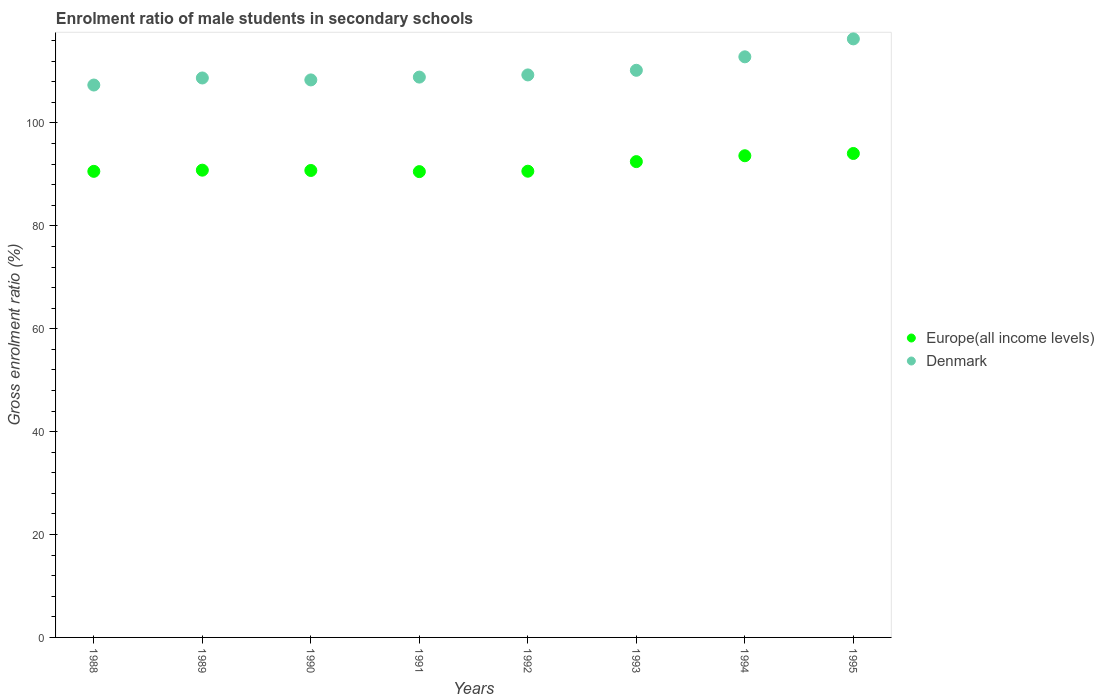How many different coloured dotlines are there?
Your response must be concise. 2. What is the enrolment ratio of male students in secondary schools in Denmark in 1990?
Your answer should be very brief. 108.37. Across all years, what is the maximum enrolment ratio of male students in secondary schools in Denmark?
Provide a succinct answer. 116.35. Across all years, what is the minimum enrolment ratio of male students in secondary schools in Europe(all income levels)?
Your answer should be very brief. 90.55. What is the total enrolment ratio of male students in secondary schools in Denmark in the graph?
Make the answer very short. 882.23. What is the difference between the enrolment ratio of male students in secondary schools in Europe(all income levels) in 1988 and that in 1991?
Keep it short and to the point. 0.05. What is the difference between the enrolment ratio of male students in secondary schools in Europe(all income levels) in 1989 and the enrolment ratio of male students in secondary schools in Denmark in 1990?
Provide a short and direct response. -17.54. What is the average enrolment ratio of male students in secondary schools in Denmark per year?
Your response must be concise. 110.28. In the year 1991, what is the difference between the enrolment ratio of male students in secondary schools in Europe(all income levels) and enrolment ratio of male students in secondary schools in Denmark?
Your answer should be very brief. -18.37. What is the ratio of the enrolment ratio of male students in secondary schools in Europe(all income levels) in 1993 to that in 1994?
Keep it short and to the point. 0.99. What is the difference between the highest and the second highest enrolment ratio of male students in secondary schools in Denmark?
Ensure brevity in your answer.  3.49. What is the difference between the highest and the lowest enrolment ratio of male students in secondary schools in Europe(all income levels)?
Provide a succinct answer. 3.52. Is the sum of the enrolment ratio of male students in secondary schools in Denmark in 1989 and 1993 greater than the maximum enrolment ratio of male students in secondary schools in Europe(all income levels) across all years?
Make the answer very short. Yes. Does the enrolment ratio of male students in secondary schools in Denmark monotonically increase over the years?
Your answer should be compact. No. Is the enrolment ratio of male students in secondary schools in Denmark strictly greater than the enrolment ratio of male students in secondary schools in Europe(all income levels) over the years?
Your response must be concise. Yes. How many dotlines are there?
Offer a very short reply. 2. What is the difference between two consecutive major ticks on the Y-axis?
Your answer should be compact. 20. Does the graph contain grids?
Your answer should be compact. No. How many legend labels are there?
Your response must be concise. 2. How are the legend labels stacked?
Make the answer very short. Vertical. What is the title of the graph?
Your answer should be very brief. Enrolment ratio of male students in secondary schools. What is the Gross enrolment ratio (%) of Europe(all income levels) in 1988?
Give a very brief answer. 90.6. What is the Gross enrolment ratio (%) of Denmark in 1988?
Offer a terse response. 107.38. What is the Gross enrolment ratio (%) of Europe(all income levels) in 1989?
Ensure brevity in your answer.  90.83. What is the Gross enrolment ratio (%) of Denmark in 1989?
Give a very brief answer. 108.75. What is the Gross enrolment ratio (%) in Europe(all income levels) in 1990?
Provide a succinct answer. 90.77. What is the Gross enrolment ratio (%) in Denmark in 1990?
Offer a terse response. 108.37. What is the Gross enrolment ratio (%) of Europe(all income levels) in 1991?
Give a very brief answer. 90.55. What is the Gross enrolment ratio (%) in Denmark in 1991?
Offer a very short reply. 108.92. What is the Gross enrolment ratio (%) of Europe(all income levels) in 1992?
Make the answer very short. 90.63. What is the Gross enrolment ratio (%) in Denmark in 1992?
Provide a succinct answer. 109.35. What is the Gross enrolment ratio (%) in Europe(all income levels) in 1993?
Your answer should be compact. 92.49. What is the Gross enrolment ratio (%) of Denmark in 1993?
Offer a terse response. 110.25. What is the Gross enrolment ratio (%) in Europe(all income levels) in 1994?
Offer a terse response. 93.63. What is the Gross enrolment ratio (%) in Denmark in 1994?
Ensure brevity in your answer.  112.86. What is the Gross enrolment ratio (%) in Europe(all income levels) in 1995?
Your answer should be very brief. 94.07. What is the Gross enrolment ratio (%) in Denmark in 1995?
Your answer should be compact. 116.35. Across all years, what is the maximum Gross enrolment ratio (%) in Europe(all income levels)?
Provide a succinct answer. 94.07. Across all years, what is the maximum Gross enrolment ratio (%) of Denmark?
Give a very brief answer. 116.35. Across all years, what is the minimum Gross enrolment ratio (%) of Europe(all income levels)?
Provide a succinct answer. 90.55. Across all years, what is the minimum Gross enrolment ratio (%) of Denmark?
Your response must be concise. 107.38. What is the total Gross enrolment ratio (%) in Europe(all income levels) in the graph?
Your answer should be compact. 733.58. What is the total Gross enrolment ratio (%) of Denmark in the graph?
Your answer should be compact. 882.23. What is the difference between the Gross enrolment ratio (%) in Europe(all income levels) in 1988 and that in 1989?
Give a very brief answer. -0.23. What is the difference between the Gross enrolment ratio (%) in Denmark in 1988 and that in 1989?
Your response must be concise. -1.37. What is the difference between the Gross enrolment ratio (%) in Europe(all income levels) in 1988 and that in 1990?
Your answer should be very brief. -0.17. What is the difference between the Gross enrolment ratio (%) of Denmark in 1988 and that in 1990?
Make the answer very short. -0.99. What is the difference between the Gross enrolment ratio (%) in Europe(all income levels) in 1988 and that in 1991?
Provide a short and direct response. 0.05. What is the difference between the Gross enrolment ratio (%) of Denmark in 1988 and that in 1991?
Your answer should be compact. -1.54. What is the difference between the Gross enrolment ratio (%) in Europe(all income levels) in 1988 and that in 1992?
Ensure brevity in your answer.  -0.03. What is the difference between the Gross enrolment ratio (%) in Denmark in 1988 and that in 1992?
Keep it short and to the point. -1.97. What is the difference between the Gross enrolment ratio (%) of Europe(all income levels) in 1988 and that in 1993?
Ensure brevity in your answer.  -1.89. What is the difference between the Gross enrolment ratio (%) in Denmark in 1988 and that in 1993?
Your answer should be very brief. -2.87. What is the difference between the Gross enrolment ratio (%) of Europe(all income levels) in 1988 and that in 1994?
Your answer should be compact. -3.03. What is the difference between the Gross enrolment ratio (%) in Denmark in 1988 and that in 1994?
Offer a very short reply. -5.48. What is the difference between the Gross enrolment ratio (%) of Europe(all income levels) in 1988 and that in 1995?
Give a very brief answer. -3.47. What is the difference between the Gross enrolment ratio (%) in Denmark in 1988 and that in 1995?
Give a very brief answer. -8.97. What is the difference between the Gross enrolment ratio (%) of Europe(all income levels) in 1989 and that in 1990?
Give a very brief answer. 0.06. What is the difference between the Gross enrolment ratio (%) of Denmark in 1989 and that in 1990?
Your response must be concise. 0.38. What is the difference between the Gross enrolment ratio (%) in Europe(all income levels) in 1989 and that in 1991?
Ensure brevity in your answer.  0.28. What is the difference between the Gross enrolment ratio (%) of Denmark in 1989 and that in 1991?
Ensure brevity in your answer.  -0.17. What is the difference between the Gross enrolment ratio (%) of Europe(all income levels) in 1989 and that in 1992?
Your response must be concise. 0.2. What is the difference between the Gross enrolment ratio (%) of Denmark in 1989 and that in 1992?
Provide a short and direct response. -0.59. What is the difference between the Gross enrolment ratio (%) in Europe(all income levels) in 1989 and that in 1993?
Your answer should be very brief. -1.66. What is the difference between the Gross enrolment ratio (%) of Denmark in 1989 and that in 1993?
Make the answer very short. -1.49. What is the difference between the Gross enrolment ratio (%) in Europe(all income levels) in 1989 and that in 1994?
Ensure brevity in your answer.  -2.8. What is the difference between the Gross enrolment ratio (%) of Denmark in 1989 and that in 1994?
Make the answer very short. -4.11. What is the difference between the Gross enrolment ratio (%) in Europe(all income levels) in 1989 and that in 1995?
Offer a very short reply. -3.24. What is the difference between the Gross enrolment ratio (%) in Denmark in 1989 and that in 1995?
Ensure brevity in your answer.  -7.6. What is the difference between the Gross enrolment ratio (%) of Europe(all income levels) in 1990 and that in 1991?
Your answer should be very brief. 0.22. What is the difference between the Gross enrolment ratio (%) of Denmark in 1990 and that in 1991?
Keep it short and to the point. -0.55. What is the difference between the Gross enrolment ratio (%) in Europe(all income levels) in 1990 and that in 1992?
Make the answer very short. 0.14. What is the difference between the Gross enrolment ratio (%) in Denmark in 1990 and that in 1992?
Provide a succinct answer. -0.97. What is the difference between the Gross enrolment ratio (%) in Europe(all income levels) in 1990 and that in 1993?
Your response must be concise. -1.72. What is the difference between the Gross enrolment ratio (%) in Denmark in 1990 and that in 1993?
Provide a short and direct response. -1.87. What is the difference between the Gross enrolment ratio (%) of Europe(all income levels) in 1990 and that in 1994?
Provide a succinct answer. -2.86. What is the difference between the Gross enrolment ratio (%) of Denmark in 1990 and that in 1994?
Keep it short and to the point. -4.49. What is the difference between the Gross enrolment ratio (%) in Europe(all income levels) in 1990 and that in 1995?
Give a very brief answer. -3.3. What is the difference between the Gross enrolment ratio (%) of Denmark in 1990 and that in 1995?
Ensure brevity in your answer.  -7.98. What is the difference between the Gross enrolment ratio (%) in Europe(all income levels) in 1991 and that in 1992?
Give a very brief answer. -0.08. What is the difference between the Gross enrolment ratio (%) in Denmark in 1991 and that in 1992?
Your response must be concise. -0.42. What is the difference between the Gross enrolment ratio (%) in Europe(all income levels) in 1991 and that in 1993?
Offer a terse response. -1.94. What is the difference between the Gross enrolment ratio (%) of Denmark in 1991 and that in 1993?
Offer a terse response. -1.33. What is the difference between the Gross enrolment ratio (%) in Europe(all income levels) in 1991 and that in 1994?
Provide a short and direct response. -3.09. What is the difference between the Gross enrolment ratio (%) in Denmark in 1991 and that in 1994?
Provide a succinct answer. -3.94. What is the difference between the Gross enrolment ratio (%) of Europe(all income levels) in 1991 and that in 1995?
Offer a terse response. -3.52. What is the difference between the Gross enrolment ratio (%) in Denmark in 1991 and that in 1995?
Make the answer very short. -7.43. What is the difference between the Gross enrolment ratio (%) in Europe(all income levels) in 1992 and that in 1993?
Your answer should be compact. -1.87. What is the difference between the Gross enrolment ratio (%) of Denmark in 1992 and that in 1993?
Offer a very short reply. -0.9. What is the difference between the Gross enrolment ratio (%) of Europe(all income levels) in 1992 and that in 1994?
Your answer should be very brief. -3.01. What is the difference between the Gross enrolment ratio (%) in Denmark in 1992 and that in 1994?
Keep it short and to the point. -3.52. What is the difference between the Gross enrolment ratio (%) in Europe(all income levels) in 1992 and that in 1995?
Your answer should be compact. -3.45. What is the difference between the Gross enrolment ratio (%) in Denmark in 1992 and that in 1995?
Provide a short and direct response. -7. What is the difference between the Gross enrolment ratio (%) in Europe(all income levels) in 1993 and that in 1994?
Ensure brevity in your answer.  -1.14. What is the difference between the Gross enrolment ratio (%) in Denmark in 1993 and that in 1994?
Your answer should be compact. -2.62. What is the difference between the Gross enrolment ratio (%) of Europe(all income levels) in 1993 and that in 1995?
Offer a very short reply. -1.58. What is the difference between the Gross enrolment ratio (%) in Denmark in 1993 and that in 1995?
Keep it short and to the point. -6.1. What is the difference between the Gross enrolment ratio (%) in Europe(all income levels) in 1994 and that in 1995?
Provide a succinct answer. -0.44. What is the difference between the Gross enrolment ratio (%) of Denmark in 1994 and that in 1995?
Make the answer very short. -3.49. What is the difference between the Gross enrolment ratio (%) in Europe(all income levels) in 1988 and the Gross enrolment ratio (%) in Denmark in 1989?
Provide a succinct answer. -18.15. What is the difference between the Gross enrolment ratio (%) of Europe(all income levels) in 1988 and the Gross enrolment ratio (%) of Denmark in 1990?
Provide a succinct answer. -17.77. What is the difference between the Gross enrolment ratio (%) in Europe(all income levels) in 1988 and the Gross enrolment ratio (%) in Denmark in 1991?
Give a very brief answer. -18.32. What is the difference between the Gross enrolment ratio (%) of Europe(all income levels) in 1988 and the Gross enrolment ratio (%) of Denmark in 1992?
Your response must be concise. -18.74. What is the difference between the Gross enrolment ratio (%) in Europe(all income levels) in 1988 and the Gross enrolment ratio (%) in Denmark in 1993?
Give a very brief answer. -19.64. What is the difference between the Gross enrolment ratio (%) of Europe(all income levels) in 1988 and the Gross enrolment ratio (%) of Denmark in 1994?
Your answer should be compact. -22.26. What is the difference between the Gross enrolment ratio (%) of Europe(all income levels) in 1988 and the Gross enrolment ratio (%) of Denmark in 1995?
Provide a succinct answer. -25.75. What is the difference between the Gross enrolment ratio (%) of Europe(all income levels) in 1989 and the Gross enrolment ratio (%) of Denmark in 1990?
Your answer should be very brief. -17.54. What is the difference between the Gross enrolment ratio (%) in Europe(all income levels) in 1989 and the Gross enrolment ratio (%) in Denmark in 1991?
Make the answer very short. -18.09. What is the difference between the Gross enrolment ratio (%) of Europe(all income levels) in 1989 and the Gross enrolment ratio (%) of Denmark in 1992?
Your response must be concise. -18.51. What is the difference between the Gross enrolment ratio (%) of Europe(all income levels) in 1989 and the Gross enrolment ratio (%) of Denmark in 1993?
Make the answer very short. -19.42. What is the difference between the Gross enrolment ratio (%) of Europe(all income levels) in 1989 and the Gross enrolment ratio (%) of Denmark in 1994?
Offer a terse response. -22.03. What is the difference between the Gross enrolment ratio (%) of Europe(all income levels) in 1989 and the Gross enrolment ratio (%) of Denmark in 1995?
Offer a very short reply. -25.52. What is the difference between the Gross enrolment ratio (%) in Europe(all income levels) in 1990 and the Gross enrolment ratio (%) in Denmark in 1991?
Your answer should be compact. -18.15. What is the difference between the Gross enrolment ratio (%) in Europe(all income levels) in 1990 and the Gross enrolment ratio (%) in Denmark in 1992?
Your response must be concise. -18.57. What is the difference between the Gross enrolment ratio (%) in Europe(all income levels) in 1990 and the Gross enrolment ratio (%) in Denmark in 1993?
Offer a very short reply. -19.48. What is the difference between the Gross enrolment ratio (%) in Europe(all income levels) in 1990 and the Gross enrolment ratio (%) in Denmark in 1994?
Give a very brief answer. -22.09. What is the difference between the Gross enrolment ratio (%) in Europe(all income levels) in 1990 and the Gross enrolment ratio (%) in Denmark in 1995?
Keep it short and to the point. -25.58. What is the difference between the Gross enrolment ratio (%) in Europe(all income levels) in 1991 and the Gross enrolment ratio (%) in Denmark in 1992?
Keep it short and to the point. -18.8. What is the difference between the Gross enrolment ratio (%) in Europe(all income levels) in 1991 and the Gross enrolment ratio (%) in Denmark in 1993?
Your response must be concise. -19.7. What is the difference between the Gross enrolment ratio (%) of Europe(all income levels) in 1991 and the Gross enrolment ratio (%) of Denmark in 1994?
Make the answer very short. -22.31. What is the difference between the Gross enrolment ratio (%) of Europe(all income levels) in 1991 and the Gross enrolment ratio (%) of Denmark in 1995?
Give a very brief answer. -25.8. What is the difference between the Gross enrolment ratio (%) in Europe(all income levels) in 1992 and the Gross enrolment ratio (%) in Denmark in 1993?
Offer a terse response. -19.62. What is the difference between the Gross enrolment ratio (%) of Europe(all income levels) in 1992 and the Gross enrolment ratio (%) of Denmark in 1994?
Offer a terse response. -22.24. What is the difference between the Gross enrolment ratio (%) of Europe(all income levels) in 1992 and the Gross enrolment ratio (%) of Denmark in 1995?
Your answer should be compact. -25.72. What is the difference between the Gross enrolment ratio (%) of Europe(all income levels) in 1993 and the Gross enrolment ratio (%) of Denmark in 1994?
Provide a succinct answer. -20.37. What is the difference between the Gross enrolment ratio (%) in Europe(all income levels) in 1993 and the Gross enrolment ratio (%) in Denmark in 1995?
Your answer should be compact. -23.86. What is the difference between the Gross enrolment ratio (%) of Europe(all income levels) in 1994 and the Gross enrolment ratio (%) of Denmark in 1995?
Ensure brevity in your answer.  -22.72. What is the average Gross enrolment ratio (%) of Europe(all income levels) per year?
Keep it short and to the point. 91.7. What is the average Gross enrolment ratio (%) in Denmark per year?
Provide a short and direct response. 110.28. In the year 1988, what is the difference between the Gross enrolment ratio (%) of Europe(all income levels) and Gross enrolment ratio (%) of Denmark?
Provide a short and direct response. -16.78. In the year 1989, what is the difference between the Gross enrolment ratio (%) in Europe(all income levels) and Gross enrolment ratio (%) in Denmark?
Give a very brief answer. -17.92. In the year 1990, what is the difference between the Gross enrolment ratio (%) in Europe(all income levels) and Gross enrolment ratio (%) in Denmark?
Your answer should be very brief. -17.6. In the year 1991, what is the difference between the Gross enrolment ratio (%) in Europe(all income levels) and Gross enrolment ratio (%) in Denmark?
Keep it short and to the point. -18.37. In the year 1992, what is the difference between the Gross enrolment ratio (%) of Europe(all income levels) and Gross enrolment ratio (%) of Denmark?
Provide a short and direct response. -18.72. In the year 1993, what is the difference between the Gross enrolment ratio (%) of Europe(all income levels) and Gross enrolment ratio (%) of Denmark?
Give a very brief answer. -17.75. In the year 1994, what is the difference between the Gross enrolment ratio (%) in Europe(all income levels) and Gross enrolment ratio (%) in Denmark?
Offer a very short reply. -19.23. In the year 1995, what is the difference between the Gross enrolment ratio (%) in Europe(all income levels) and Gross enrolment ratio (%) in Denmark?
Offer a very short reply. -22.28. What is the ratio of the Gross enrolment ratio (%) in Denmark in 1988 to that in 1989?
Provide a succinct answer. 0.99. What is the ratio of the Gross enrolment ratio (%) of Europe(all income levels) in 1988 to that in 1991?
Make the answer very short. 1. What is the ratio of the Gross enrolment ratio (%) in Denmark in 1988 to that in 1991?
Offer a very short reply. 0.99. What is the ratio of the Gross enrolment ratio (%) of Europe(all income levels) in 1988 to that in 1992?
Your response must be concise. 1. What is the ratio of the Gross enrolment ratio (%) of Denmark in 1988 to that in 1992?
Ensure brevity in your answer.  0.98. What is the ratio of the Gross enrolment ratio (%) of Europe(all income levels) in 1988 to that in 1993?
Your answer should be compact. 0.98. What is the ratio of the Gross enrolment ratio (%) of Denmark in 1988 to that in 1993?
Offer a very short reply. 0.97. What is the ratio of the Gross enrolment ratio (%) in Europe(all income levels) in 1988 to that in 1994?
Offer a terse response. 0.97. What is the ratio of the Gross enrolment ratio (%) of Denmark in 1988 to that in 1994?
Keep it short and to the point. 0.95. What is the ratio of the Gross enrolment ratio (%) in Europe(all income levels) in 1988 to that in 1995?
Your answer should be very brief. 0.96. What is the ratio of the Gross enrolment ratio (%) in Denmark in 1988 to that in 1995?
Your answer should be compact. 0.92. What is the ratio of the Gross enrolment ratio (%) in Denmark in 1989 to that in 1990?
Your answer should be very brief. 1. What is the ratio of the Gross enrolment ratio (%) of Europe(all income levels) in 1989 to that in 1991?
Provide a succinct answer. 1. What is the ratio of the Gross enrolment ratio (%) of Europe(all income levels) in 1989 to that in 1992?
Your answer should be very brief. 1. What is the ratio of the Gross enrolment ratio (%) of Denmark in 1989 to that in 1992?
Make the answer very short. 0.99. What is the ratio of the Gross enrolment ratio (%) of Denmark in 1989 to that in 1993?
Provide a succinct answer. 0.99. What is the ratio of the Gross enrolment ratio (%) in Europe(all income levels) in 1989 to that in 1994?
Offer a very short reply. 0.97. What is the ratio of the Gross enrolment ratio (%) in Denmark in 1989 to that in 1994?
Offer a very short reply. 0.96. What is the ratio of the Gross enrolment ratio (%) of Europe(all income levels) in 1989 to that in 1995?
Your response must be concise. 0.97. What is the ratio of the Gross enrolment ratio (%) of Denmark in 1989 to that in 1995?
Provide a succinct answer. 0.93. What is the ratio of the Gross enrolment ratio (%) in Europe(all income levels) in 1990 to that in 1991?
Your response must be concise. 1. What is the ratio of the Gross enrolment ratio (%) in Denmark in 1990 to that in 1991?
Your answer should be compact. 0.99. What is the ratio of the Gross enrolment ratio (%) in Europe(all income levels) in 1990 to that in 1992?
Ensure brevity in your answer.  1. What is the ratio of the Gross enrolment ratio (%) of Denmark in 1990 to that in 1992?
Your response must be concise. 0.99. What is the ratio of the Gross enrolment ratio (%) in Europe(all income levels) in 1990 to that in 1993?
Keep it short and to the point. 0.98. What is the ratio of the Gross enrolment ratio (%) in Denmark in 1990 to that in 1993?
Offer a very short reply. 0.98. What is the ratio of the Gross enrolment ratio (%) in Europe(all income levels) in 1990 to that in 1994?
Keep it short and to the point. 0.97. What is the ratio of the Gross enrolment ratio (%) of Denmark in 1990 to that in 1994?
Provide a short and direct response. 0.96. What is the ratio of the Gross enrolment ratio (%) in Europe(all income levels) in 1990 to that in 1995?
Give a very brief answer. 0.96. What is the ratio of the Gross enrolment ratio (%) in Denmark in 1990 to that in 1995?
Ensure brevity in your answer.  0.93. What is the ratio of the Gross enrolment ratio (%) in Denmark in 1991 to that in 1992?
Provide a succinct answer. 1. What is the ratio of the Gross enrolment ratio (%) in Denmark in 1991 to that in 1993?
Your answer should be very brief. 0.99. What is the ratio of the Gross enrolment ratio (%) in Europe(all income levels) in 1991 to that in 1994?
Your response must be concise. 0.97. What is the ratio of the Gross enrolment ratio (%) in Denmark in 1991 to that in 1994?
Offer a terse response. 0.97. What is the ratio of the Gross enrolment ratio (%) in Europe(all income levels) in 1991 to that in 1995?
Your answer should be compact. 0.96. What is the ratio of the Gross enrolment ratio (%) of Denmark in 1991 to that in 1995?
Make the answer very short. 0.94. What is the ratio of the Gross enrolment ratio (%) in Europe(all income levels) in 1992 to that in 1993?
Ensure brevity in your answer.  0.98. What is the ratio of the Gross enrolment ratio (%) in Denmark in 1992 to that in 1993?
Give a very brief answer. 0.99. What is the ratio of the Gross enrolment ratio (%) in Europe(all income levels) in 1992 to that in 1994?
Keep it short and to the point. 0.97. What is the ratio of the Gross enrolment ratio (%) of Denmark in 1992 to that in 1994?
Offer a very short reply. 0.97. What is the ratio of the Gross enrolment ratio (%) of Europe(all income levels) in 1992 to that in 1995?
Provide a short and direct response. 0.96. What is the ratio of the Gross enrolment ratio (%) of Denmark in 1992 to that in 1995?
Provide a short and direct response. 0.94. What is the ratio of the Gross enrolment ratio (%) in Europe(all income levels) in 1993 to that in 1994?
Make the answer very short. 0.99. What is the ratio of the Gross enrolment ratio (%) of Denmark in 1993 to that in 1994?
Your response must be concise. 0.98. What is the ratio of the Gross enrolment ratio (%) in Europe(all income levels) in 1993 to that in 1995?
Your answer should be very brief. 0.98. What is the ratio of the Gross enrolment ratio (%) of Denmark in 1993 to that in 1995?
Keep it short and to the point. 0.95. What is the ratio of the Gross enrolment ratio (%) of Denmark in 1994 to that in 1995?
Ensure brevity in your answer.  0.97. What is the difference between the highest and the second highest Gross enrolment ratio (%) of Europe(all income levels)?
Give a very brief answer. 0.44. What is the difference between the highest and the second highest Gross enrolment ratio (%) of Denmark?
Keep it short and to the point. 3.49. What is the difference between the highest and the lowest Gross enrolment ratio (%) in Europe(all income levels)?
Offer a terse response. 3.52. What is the difference between the highest and the lowest Gross enrolment ratio (%) in Denmark?
Your answer should be compact. 8.97. 